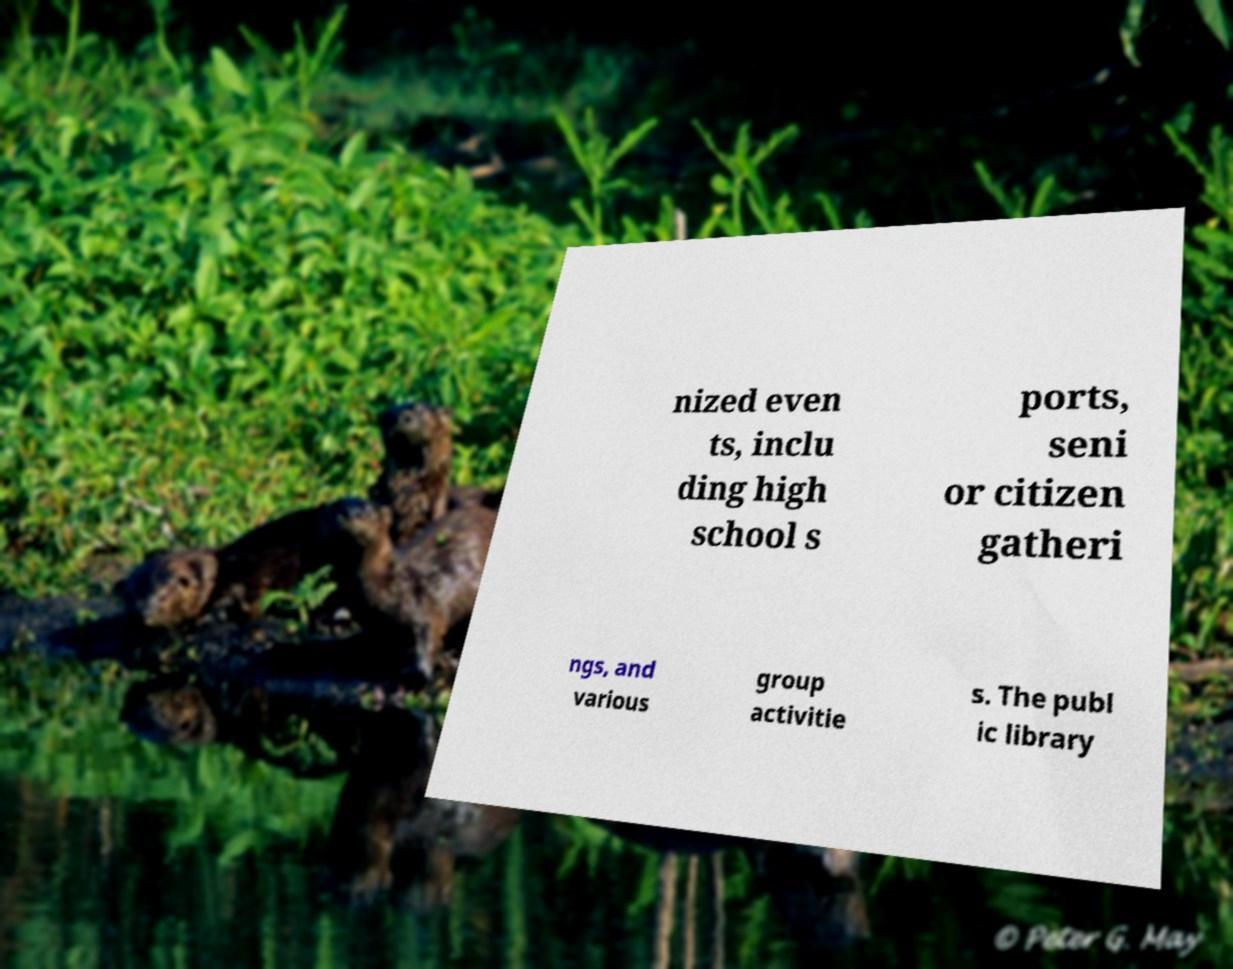Please identify and transcribe the text found in this image. nized even ts, inclu ding high school s ports, seni or citizen gatheri ngs, and various group activitie s. The publ ic library 